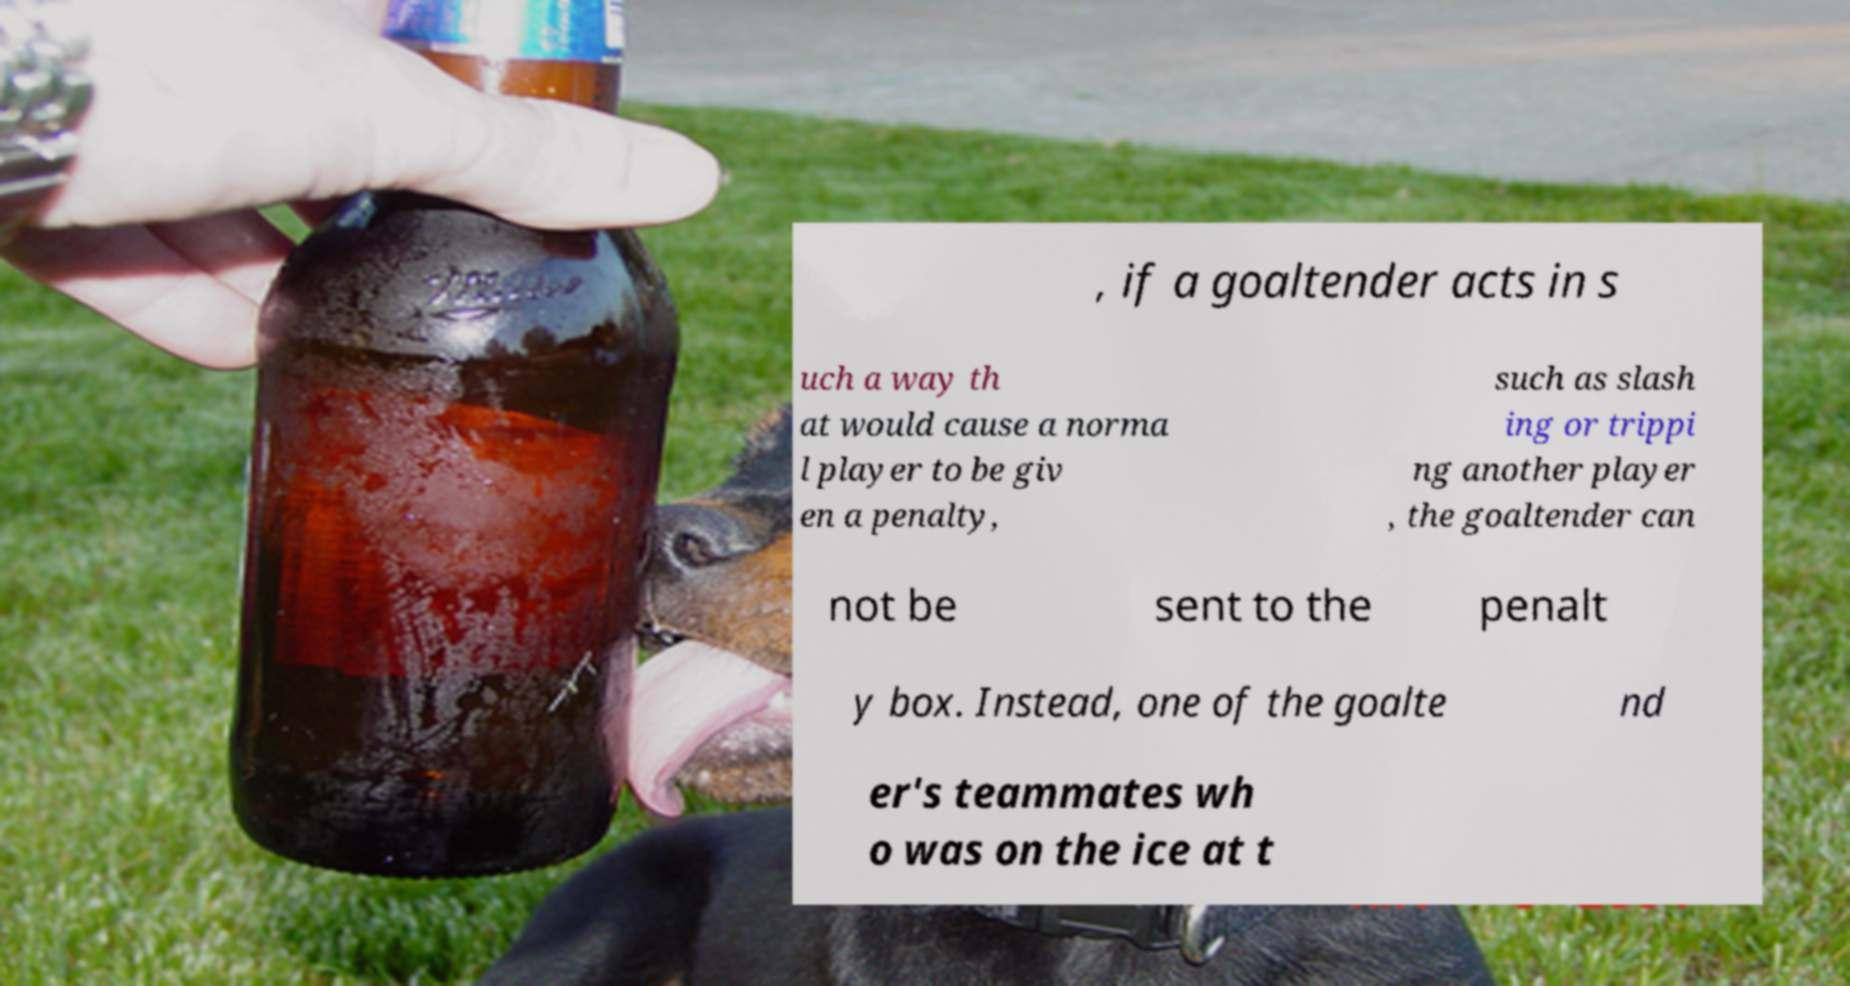Can you read and provide the text displayed in the image?This photo seems to have some interesting text. Can you extract and type it out for me? , if a goaltender acts in s uch a way th at would cause a norma l player to be giv en a penalty, such as slash ing or trippi ng another player , the goaltender can not be sent to the penalt y box. Instead, one of the goalte nd er's teammates wh o was on the ice at t 